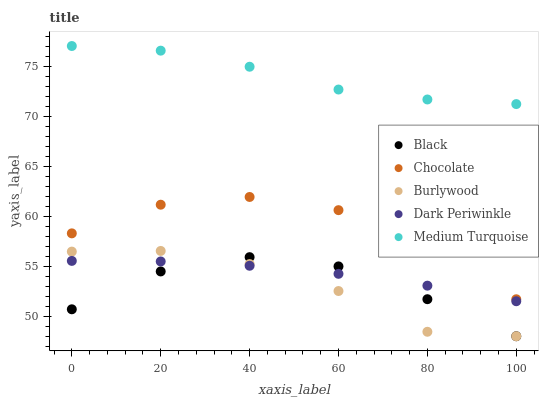Does Burlywood have the minimum area under the curve?
Answer yes or no. Yes. Does Medium Turquoise have the maximum area under the curve?
Answer yes or no. Yes. Does Black have the minimum area under the curve?
Answer yes or no. No. Does Black have the maximum area under the curve?
Answer yes or no. No. Is Dark Periwinkle the smoothest?
Answer yes or no. Yes. Is Chocolate the roughest?
Answer yes or no. Yes. Is Black the smoothest?
Answer yes or no. No. Is Black the roughest?
Answer yes or no. No. Does Burlywood have the lowest value?
Answer yes or no. Yes. Does Dark Periwinkle have the lowest value?
Answer yes or no. No. Does Medium Turquoise have the highest value?
Answer yes or no. Yes. Does Black have the highest value?
Answer yes or no. No. Is Burlywood less than Chocolate?
Answer yes or no. Yes. Is Medium Turquoise greater than Dark Periwinkle?
Answer yes or no. Yes. Does Burlywood intersect Black?
Answer yes or no. Yes. Is Burlywood less than Black?
Answer yes or no. No. Is Burlywood greater than Black?
Answer yes or no. No. Does Burlywood intersect Chocolate?
Answer yes or no. No. 